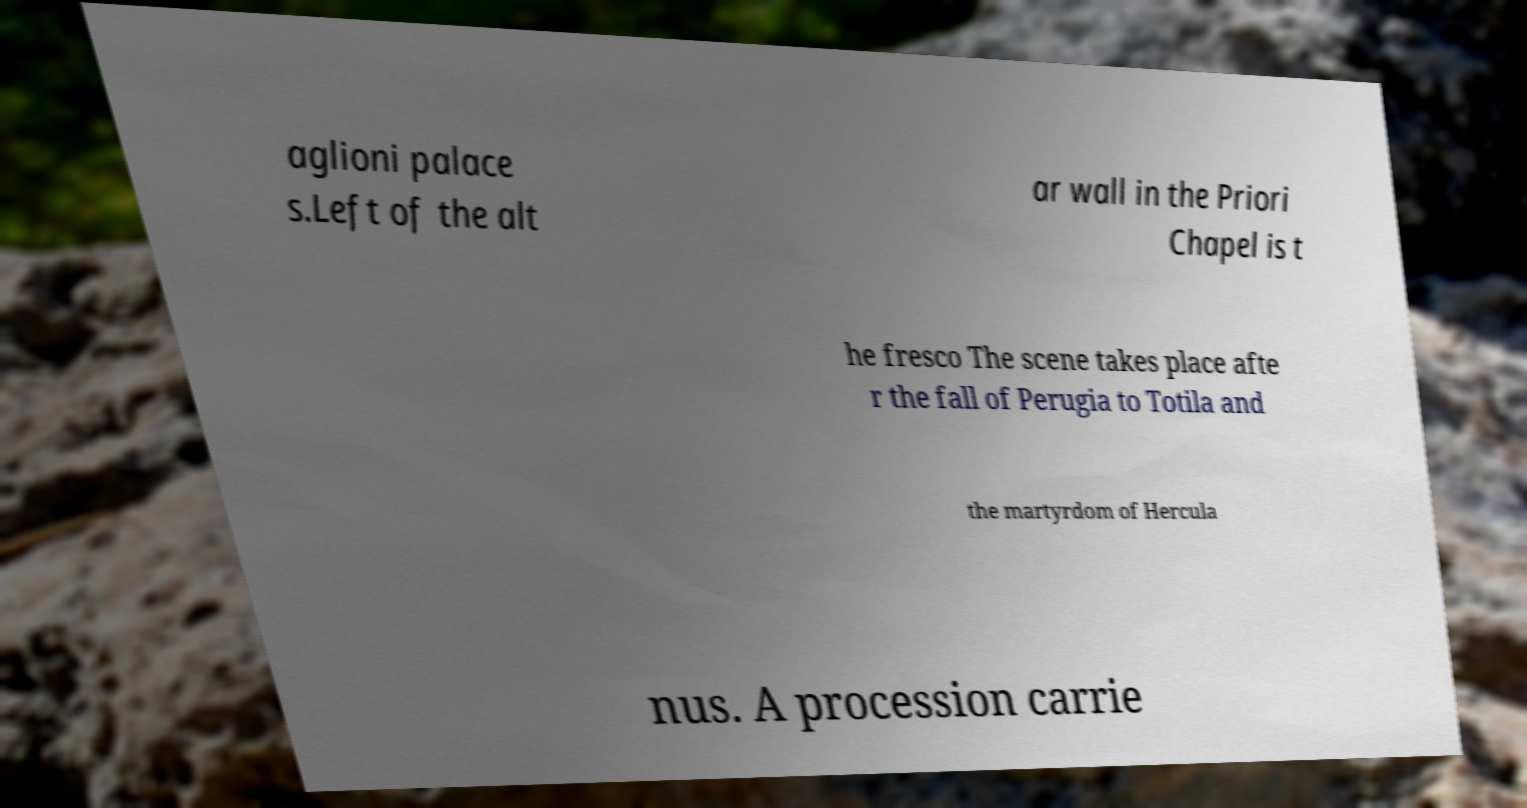Can you read and provide the text displayed in the image?This photo seems to have some interesting text. Can you extract and type it out for me? aglioni palace s.Left of the alt ar wall in the Priori Chapel is t he fresco The scene takes place afte r the fall of Perugia to Totila and the martyrdom of Hercula nus. A procession carrie 